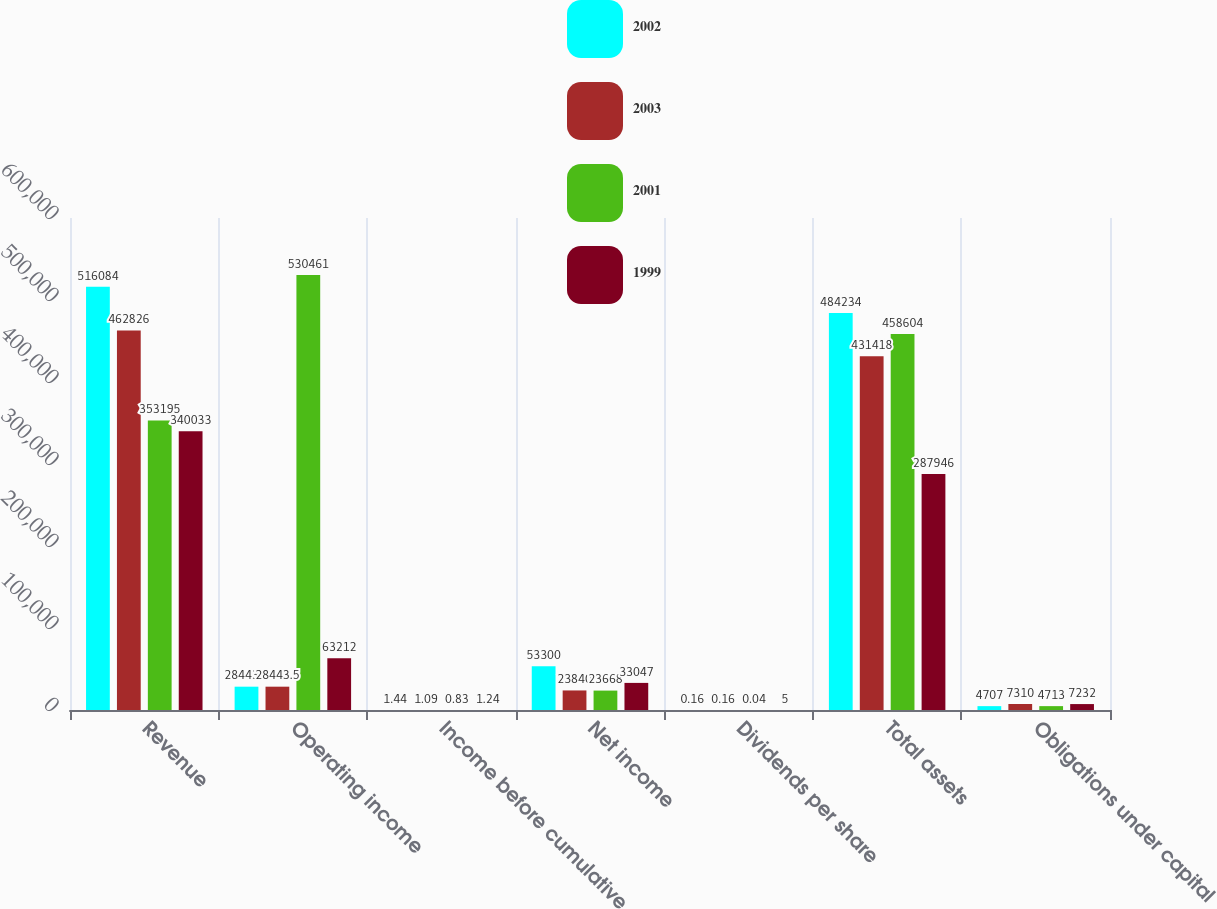Convert chart to OTSL. <chart><loc_0><loc_0><loc_500><loc_500><stacked_bar_chart><ecel><fcel>Revenue<fcel>Operating income<fcel>Income before cumulative<fcel>Net income<fcel>Dividends per share<fcel>Total assets<fcel>Obligations under capital<nl><fcel>2002<fcel>516084<fcel>28443.5<fcel>1.44<fcel>53300<fcel>0.16<fcel>484234<fcel>4707<nl><fcel>2003<fcel>462826<fcel>28443.5<fcel>1.09<fcel>23840<fcel>0.16<fcel>431418<fcel>7310<nl><fcel>2001<fcel>353195<fcel>530461<fcel>0.83<fcel>23668<fcel>0.04<fcel>458604<fcel>4713<nl><fcel>1999<fcel>340033<fcel>63212<fcel>1.24<fcel>33047<fcel>5<fcel>287946<fcel>7232<nl></chart> 